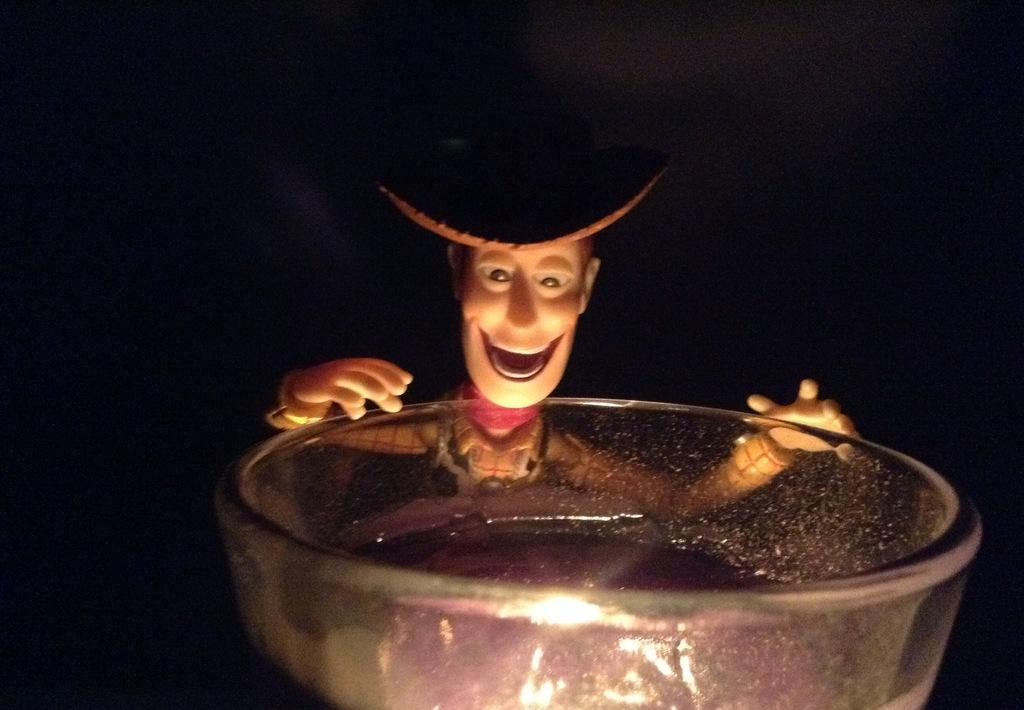What is present in the image that can hold food or liquids? There is a bowl in the image that can hold food or liquids. What type of object can be seen in the image that is typically used for play or entertainment? There is a toy in the image that is typically used for play or entertainment. What color is the background of the image? The background of the image is black in color. What type of home can be seen in the image? There is no home present in the image. 